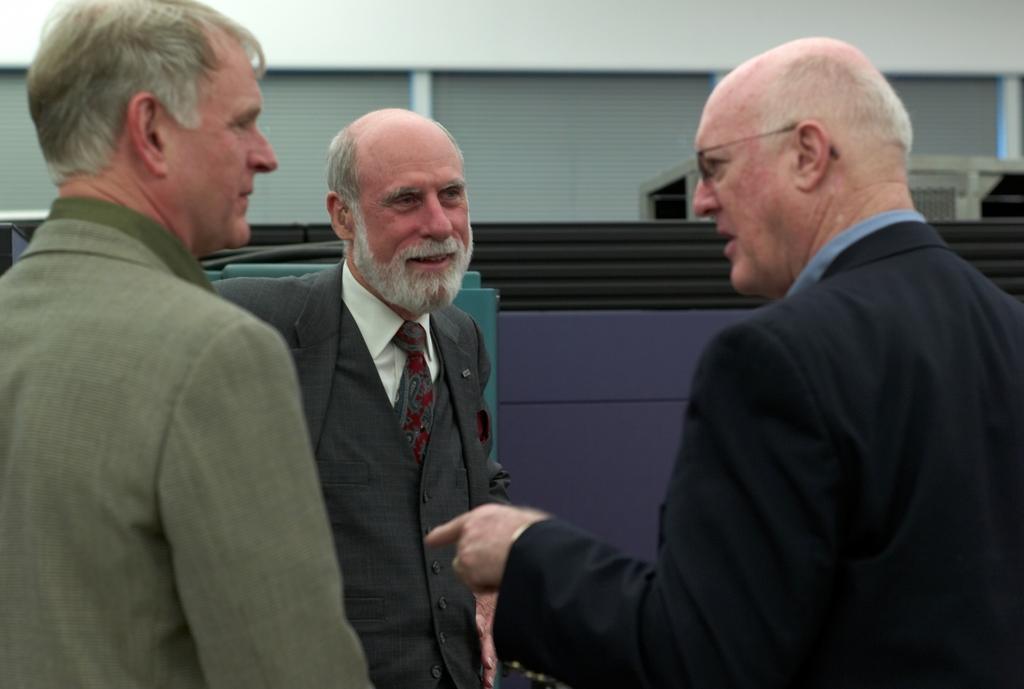Please provide a concise description of this image. Here in this picture we can see a group of old men standing over a place and all of them are wearing suits on them and the person on the right side is speaking something to them and we can see he is wearing spectacles on him and the person in the middle is smiling and behind them we can see a house present. 